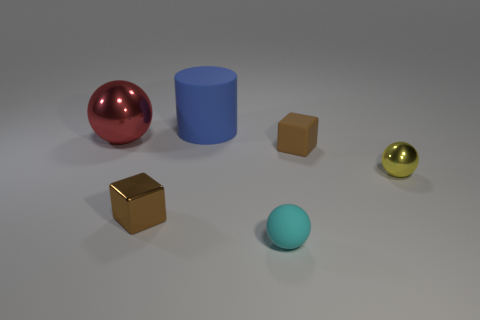There is another brown object that is the same shape as the small brown rubber thing; what size is it?
Keep it short and to the point. Small. How many red objects are the same size as the brown shiny cube?
Ensure brevity in your answer.  0. What material is the large red thing?
Offer a terse response. Metal. There is a red metal object; are there any rubber objects in front of it?
Offer a very short reply. Yes. What size is the other yellow ball that is the same material as the large ball?
Offer a terse response. Small. What number of large matte objects are the same color as the big matte cylinder?
Your response must be concise. 0. Are there fewer large metal balls that are to the left of the red thing than small shiny things that are in front of the blue thing?
Your answer should be very brief. Yes. How big is the metal object to the right of the cylinder?
Ensure brevity in your answer.  Small. Is there a blue thing made of the same material as the small cyan thing?
Your response must be concise. Yes. Do the large red thing and the blue thing have the same material?
Keep it short and to the point. No. 